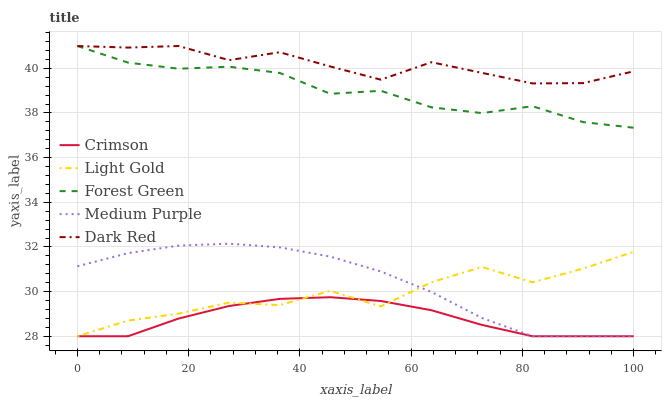Does Crimson have the minimum area under the curve?
Answer yes or no. Yes. Does Dark Red have the maximum area under the curve?
Answer yes or no. Yes. Does Medium Purple have the minimum area under the curve?
Answer yes or no. No. Does Medium Purple have the maximum area under the curve?
Answer yes or no. No. Is Crimson the smoothest?
Answer yes or no. Yes. Is Light Gold the roughest?
Answer yes or no. Yes. Is Medium Purple the smoothest?
Answer yes or no. No. Is Medium Purple the roughest?
Answer yes or no. No. Does Crimson have the lowest value?
Answer yes or no. Yes. Does Forest Green have the lowest value?
Answer yes or no. No. Does Dark Red have the highest value?
Answer yes or no. Yes. Does Medium Purple have the highest value?
Answer yes or no. No. Is Medium Purple less than Dark Red?
Answer yes or no. Yes. Is Dark Red greater than Medium Purple?
Answer yes or no. Yes. Does Medium Purple intersect Light Gold?
Answer yes or no. Yes. Is Medium Purple less than Light Gold?
Answer yes or no. No. Is Medium Purple greater than Light Gold?
Answer yes or no. No. Does Medium Purple intersect Dark Red?
Answer yes or no. No. 